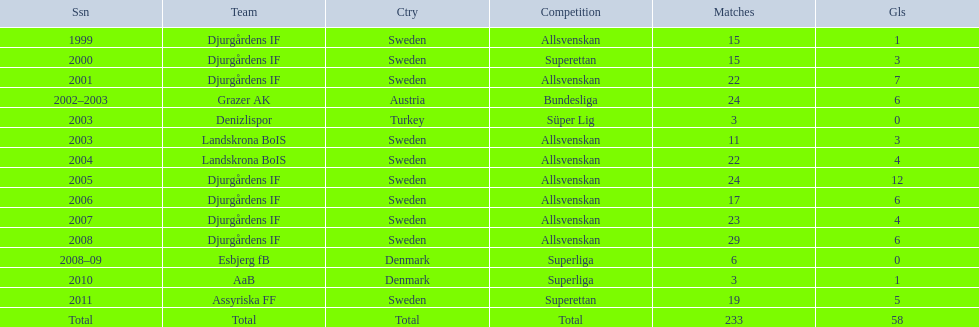What team has the most goals? Djurgårdens IF. 